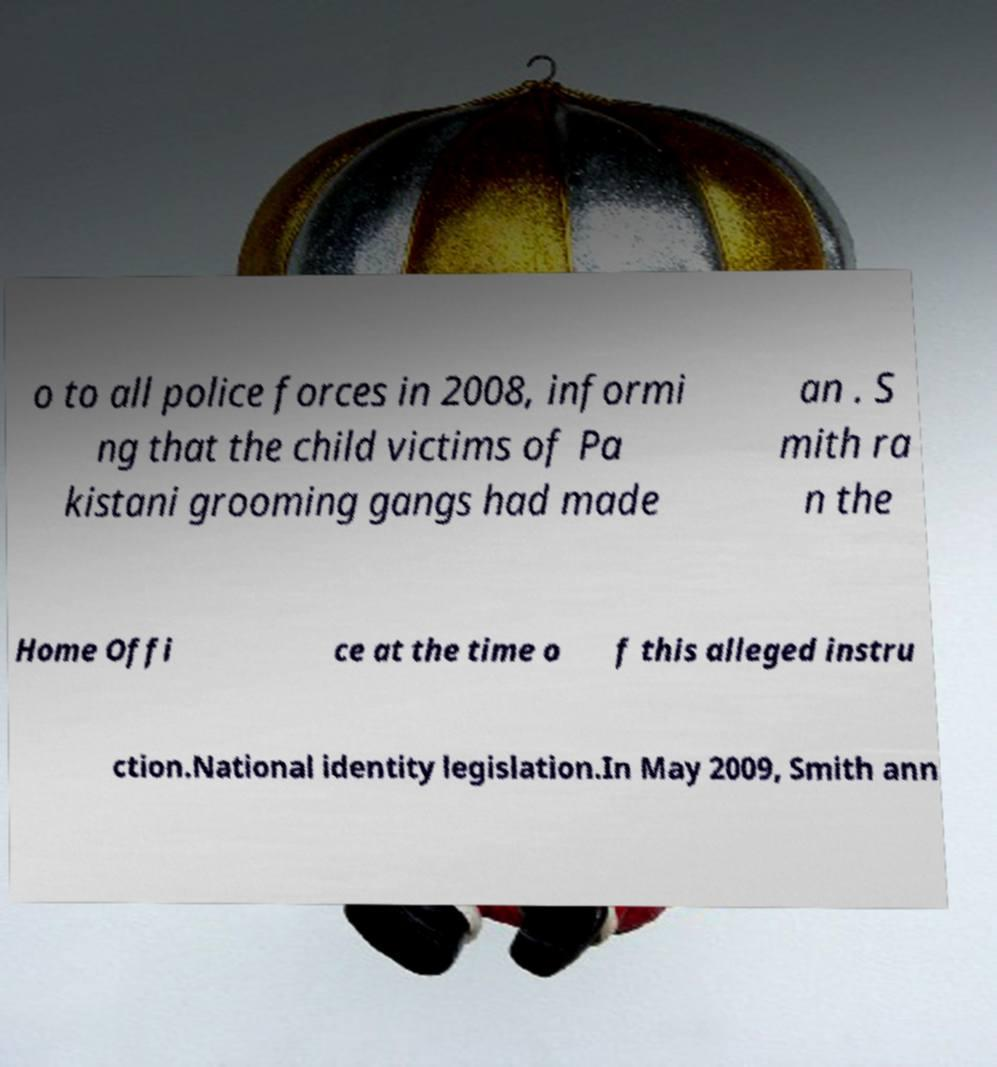I need the written content from this picture converted into text. Can you do that? o to all police forces in 2008, informi ng that the child victims of Pa kistani grooming gangs had made an . S mith ra n the Home Offi ce at the time o f this alleged instru ction.National identity legislation.In May 2009, Smith ann 